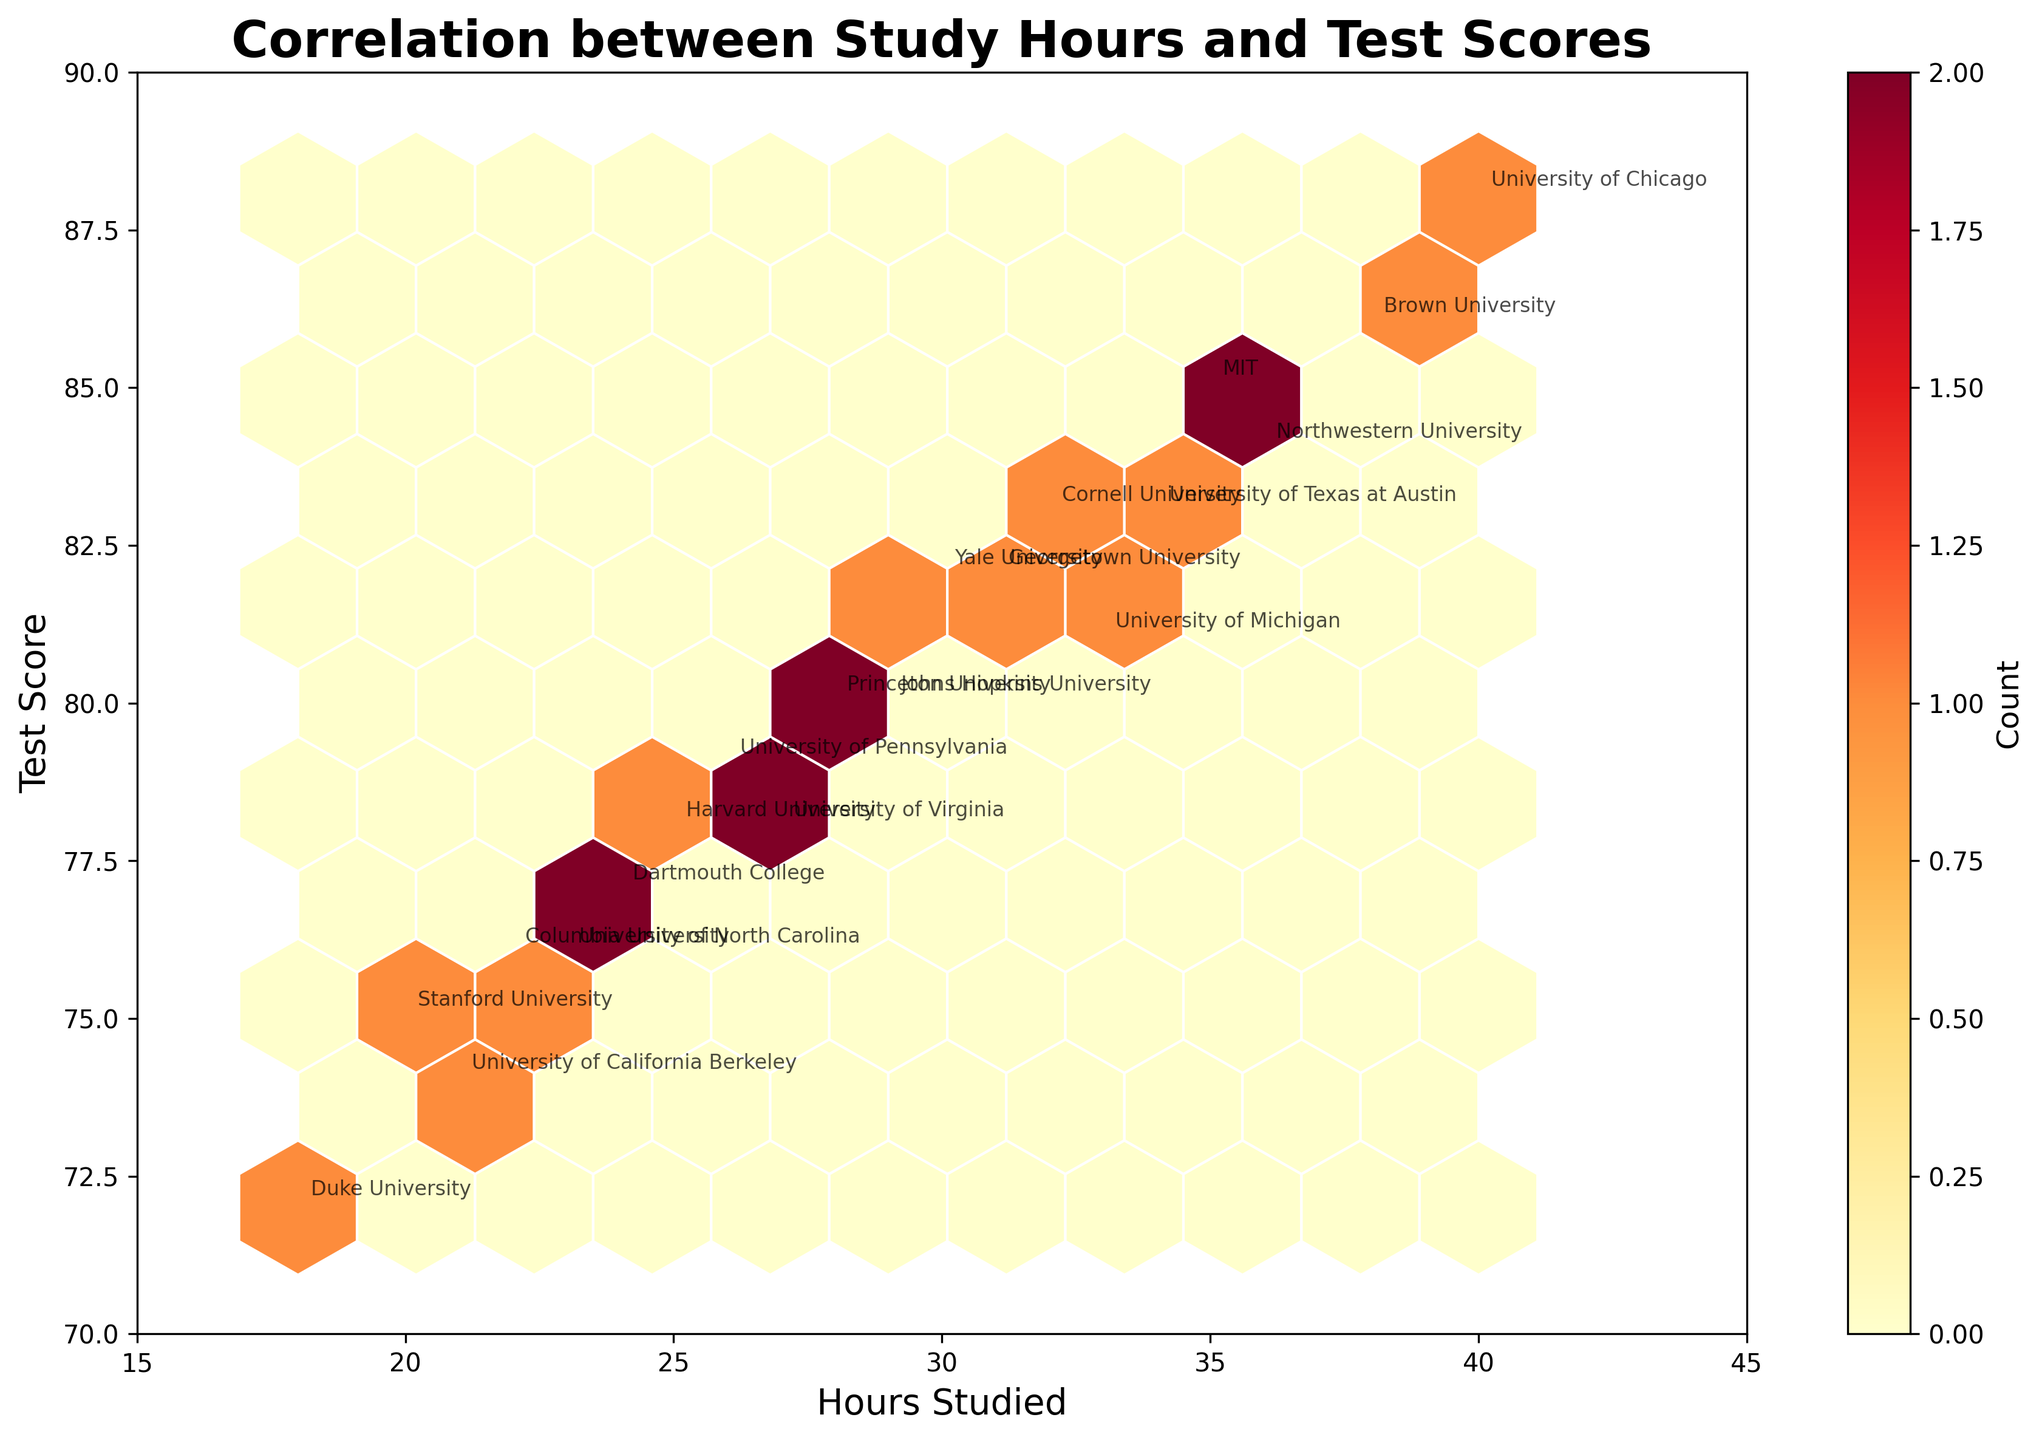What's the title of the plot? The title of the plot is displayed at the top of the figure. We can see the text "Correlation between Study Hours and Test Scores" as the title.
Answer: Correlation between Study Hours and Test Scores What are the axes labels? The labels for the axes are displayed next to each of the axes. The x-axis is labeled "Hours Studied" and the y-axis is labeled "Test Score".
Answer: Hours Studied (x-axis) and Test Score (y-axis) Which university had the highest test score? To find the highest test score, we look for the hexbin with the highest y-value and check the associated annotation. The highest point on the y-axis (88) is annotated as "University of Chicago".
Answer: University of Chicago How many hours did Stanford University students study? The hexbin containing the data of Stanford University is annotated at the point associated with it. For Stanford University, the annotation is at the 20 hours studied point.
Answer: 20 hours What is the general trend between hours studied and test scores? By observing the placement of the hexbin slots, there is a visible trend where increased hours of studying correlate with higher test scores.
Answer: Positive correlation Compare the test scores of MIT and University of California Berkeley. Which university scored higher? To compare, identify the annotations for MIT (score 85) and University of California Berkeley (score 74). MIT has a higher test score compared to UC Berkeley.
Answer: MIT Find the average number of hours studied by students from Yale University and Princeton University. Yale's point shows 30 hours and Princeton's shows 28 hours. The average is calculated as (30 + 28) / 2 = 29.
Answer: 29 Do students from Ivy League universities tend to study more than 30 hours on average? Identify universities from the Ivy League and their hours studied: Harvard (25), Yale (30), Princeton (28), Columbia (22), Cornell (32), University of Pennsylvania (26), Brown (38), Dartmouth (24) - average: (25 + 30 + 28 + 22 + 32 + 26 + 38 + 24) / 8 = 28.125, which is less than 30 hours.
Answer: No How many data points are within the hexbin plot? The hexbin plot represents data points by color clusters, and there are a total of 20 universities annotations each representing a data point.
Answer: 20 